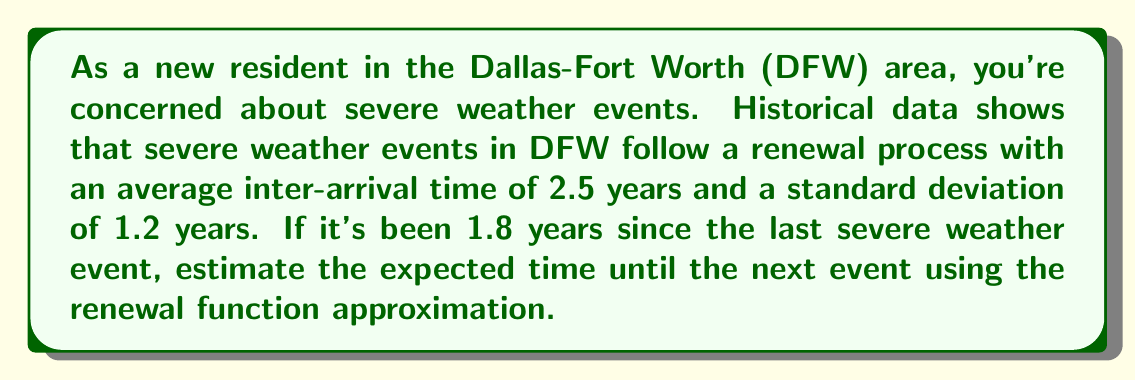Help me with this question. Let's approach this step-by-step using the renewal function approximation:

1) In a renewal process, the renewal function $m(t)$ represents the expected number of renewals (events) in the interval $(0,t]$. 

2) The renewal function approximation for large $t$ is given by:

   $$m(t) \approx \frac{t}{\mu} + \frac{\sigma^2 - \mu^2}{2\mu^2}$$

   where $\mu$ is the mean inter-arrival time and $\sigma$ is the standard deviation.

3) Given:
   $\mu = 2.5$ years
   $\sigma = 1.2$ years
   Time since last event, $t = 1.8$ years

4) Calculate $\frac{\sigma^2 - \mu^2}{2\mu^2}$:
   
   $$\frac{1.2^2 - 2.5^2}{2(2.5)^2} = -0.3576$$

5) Now, calculate $m(1.8)$:

   $$m(1.8) \approx \frac{1.8}{2.5} - 0.3576 = 0.3624$$

6) This means we expect about 0.3624 events to have occurred since the last one.

7) To find the expected time until the next event, we need to find $t$ such that $m(t) = 1$:

   $$1 = \frac{t}{2.5} - 0.3576$$
   $$1.3576 = \frac{t}{2.5}$$
   $$t = 1.3576 * 2.5 = 3.394$$

8) Since 1.8 years have already passed, the expected additional time until the next event is:

   $$3.394 - 1.8 = 1.594$$ years
Answer: 1.594 years 